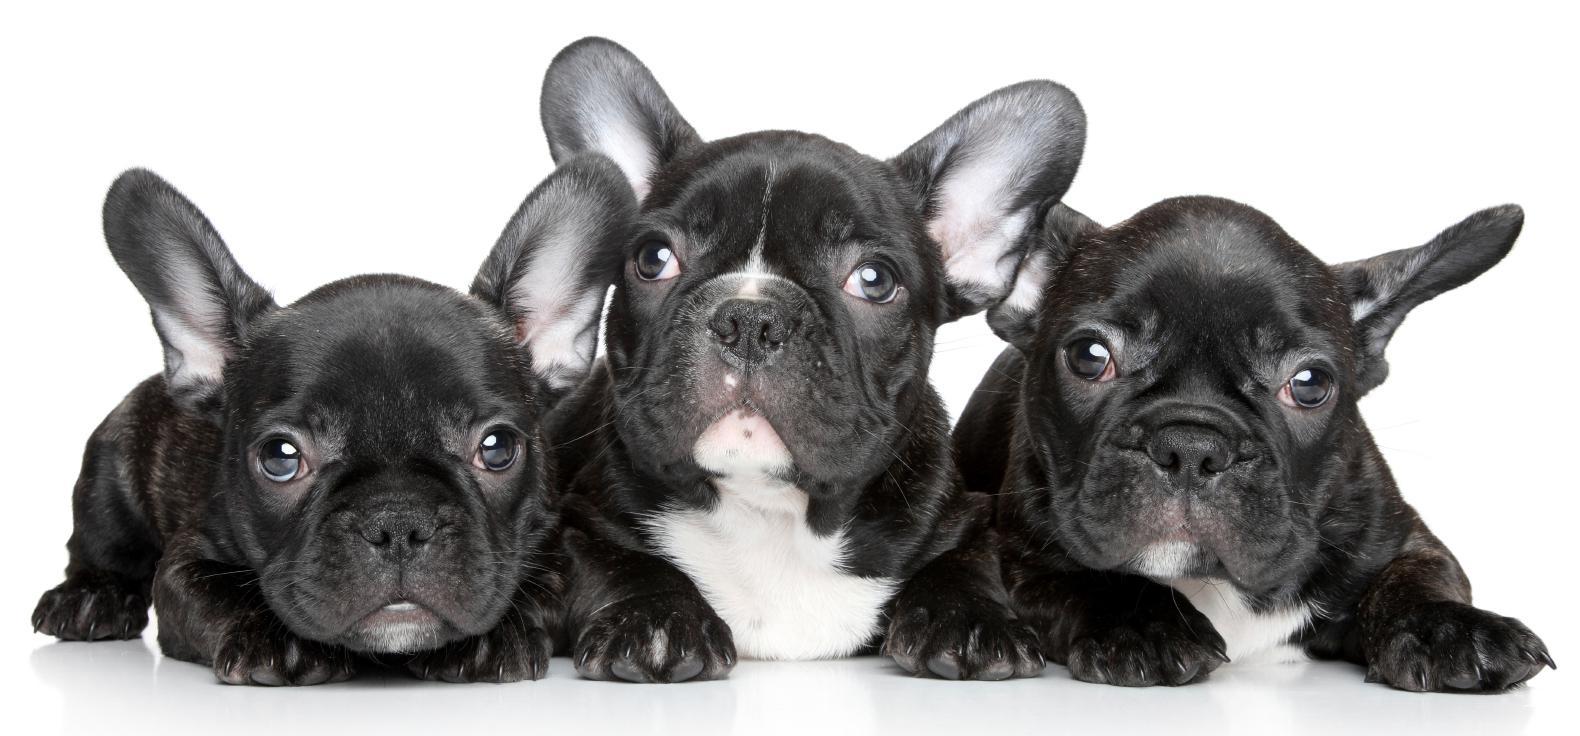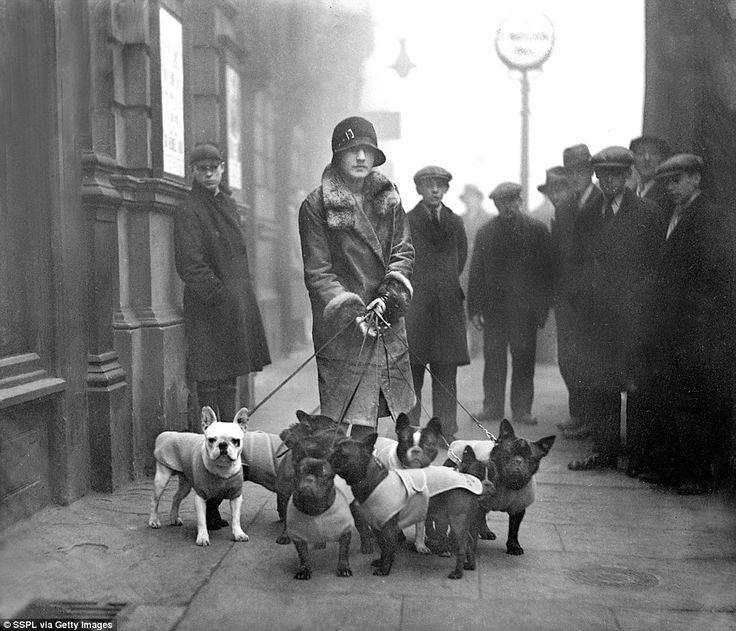The first image is the image on the left, the second image is the image on the right. Considering the images on both sides, is "There is only one dog in one of the images." valid? Answer yes or no. No. The first image is the image on the left, the second image is the image on the right. Assess this claim about the two images: "The left image contains no more than three dogs.". Correct or not? Answer yes or no. Yes. 